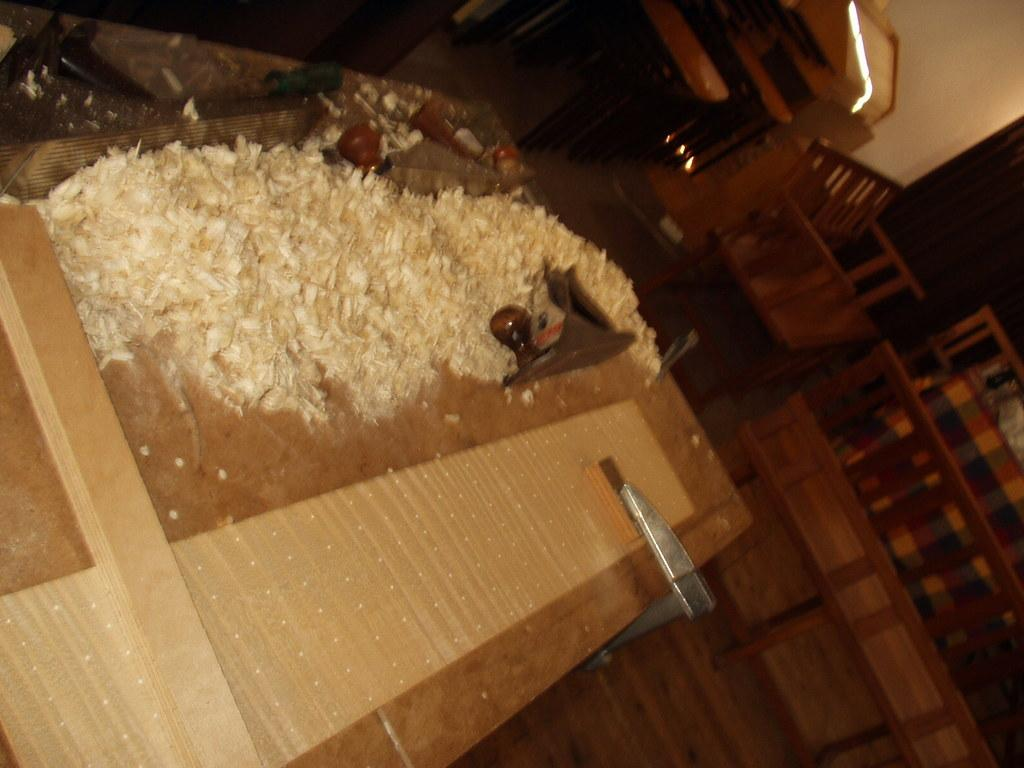What piece of furniture is present in the image? There is a table in the image. What items can be seen on the table? There are tools on the table. What part of the room is visible in the image? The floor is visible in the image. What type of seating is present in the image? There are benches in the image. What can be seen in the background of the image? There is a wall in the background of the image. What type of fruit is hanging from the wall in the image? There is no fruit hanging from the wall in the image; it only features a wall in the background. 